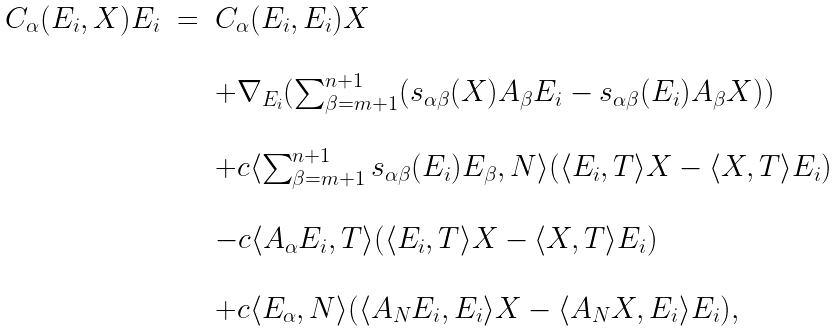<formula> <loc_0><loc_0><loc_500><loc_500>\begin{array} { l c l } C _ { \alpha } ( E _ { i } , X ) E _ { i } & = & C _ { \alpha } ( E _ { i } , E _ { i } ) X \\ \\ & & + \nabla _ { E _ { i } } ( \sum _ { \beta = m + 1 } ^ { n + 1 } ( s _ { \alpha \beta } ( X ) A _ { \beta } E _ { i } - s _ { \alpha \beta } ( E _ { i } ) A _ { \beta } X ) ) \\ \\ & & + c \langle \sum _ { \beta = m + 1 } ^ { n + 1 } s _ { \alpha \beta } ( E _ { i } ) E _ { \beta } , N \rangle ( \langle E _ { i } , T \rangle X - \langle X , T \rangle E _ { i } ) \\ \\ & & - c \langle A _ { \alpha } E _ { i } , T \rangle ( \langle E _ { i } , T \rangle X - \langle X , T \rangle E _ { i } ) \\ \\ & & + c \langle E _ { \alpha } , N \rangle ( \langle A _ { N } E _ { i } , E _ { i } \rangle X - \langle A _ { N } X , E _ { i } \rangle E _ { i } ) , \end{array}</formula> 